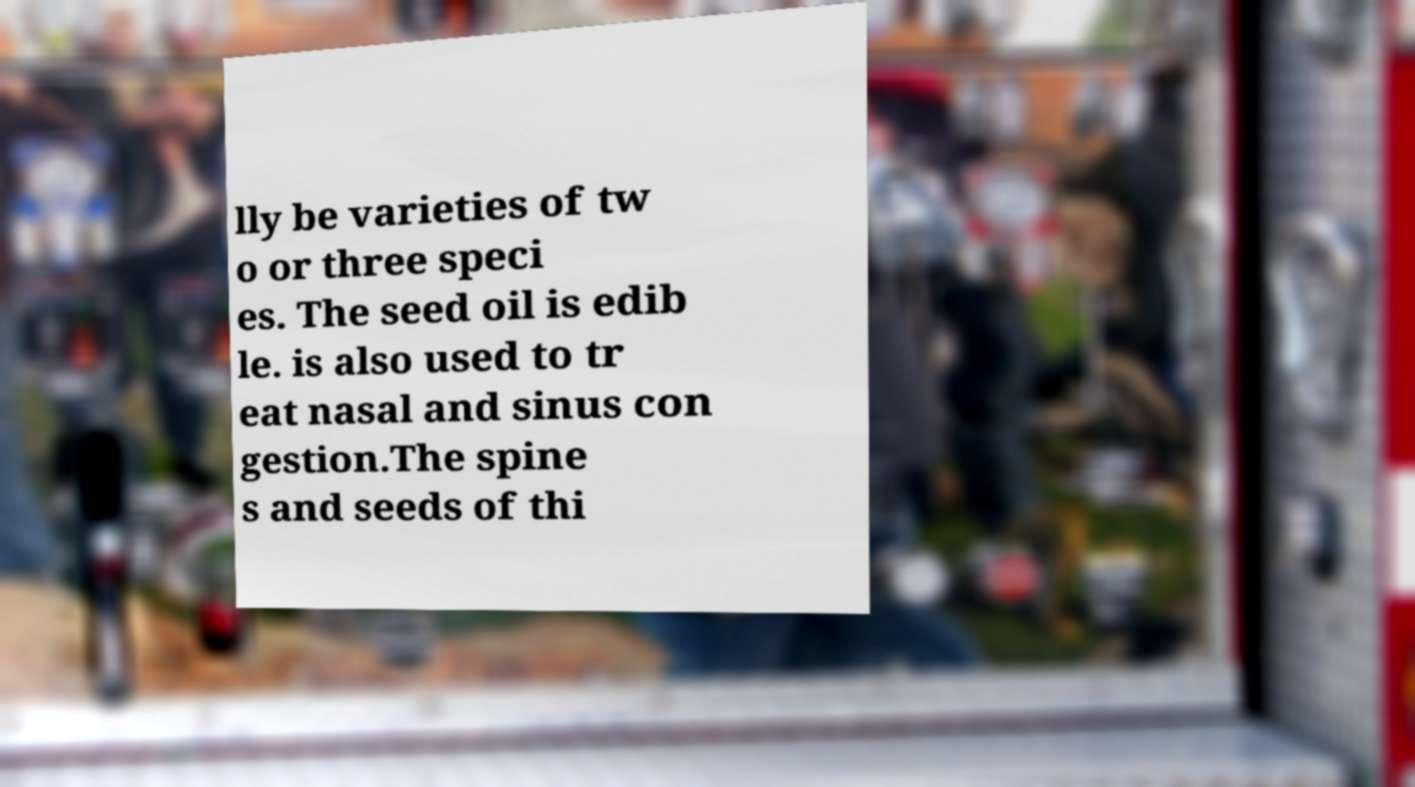Could you extract and type out the text from this image? lly be varieties of tw o or three speci es. The seed oil is edib le. is also used to tr eat nasal and sinus con gestion.The spine s and seeds of thi 